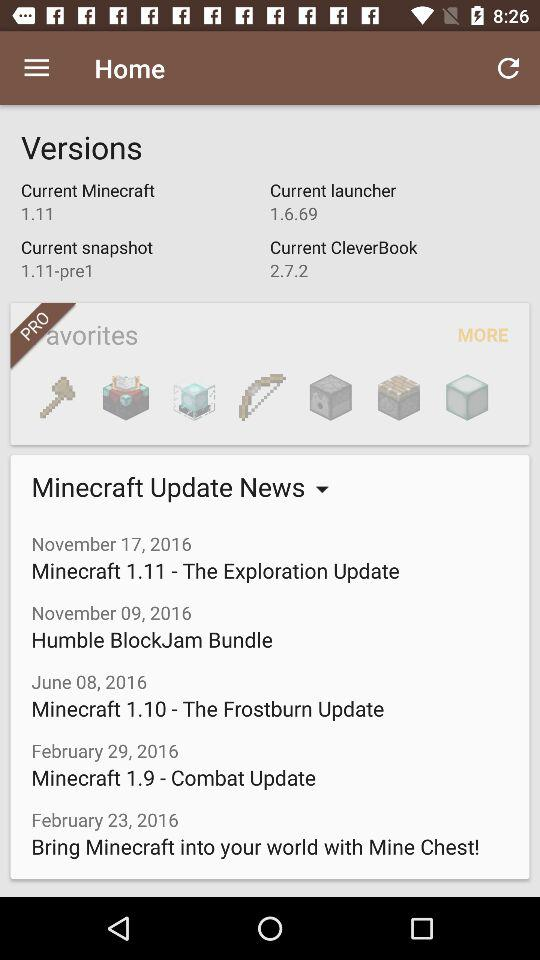When was the news about Minecraft 1.11 updated? The news was updated on November 17, 2016. 